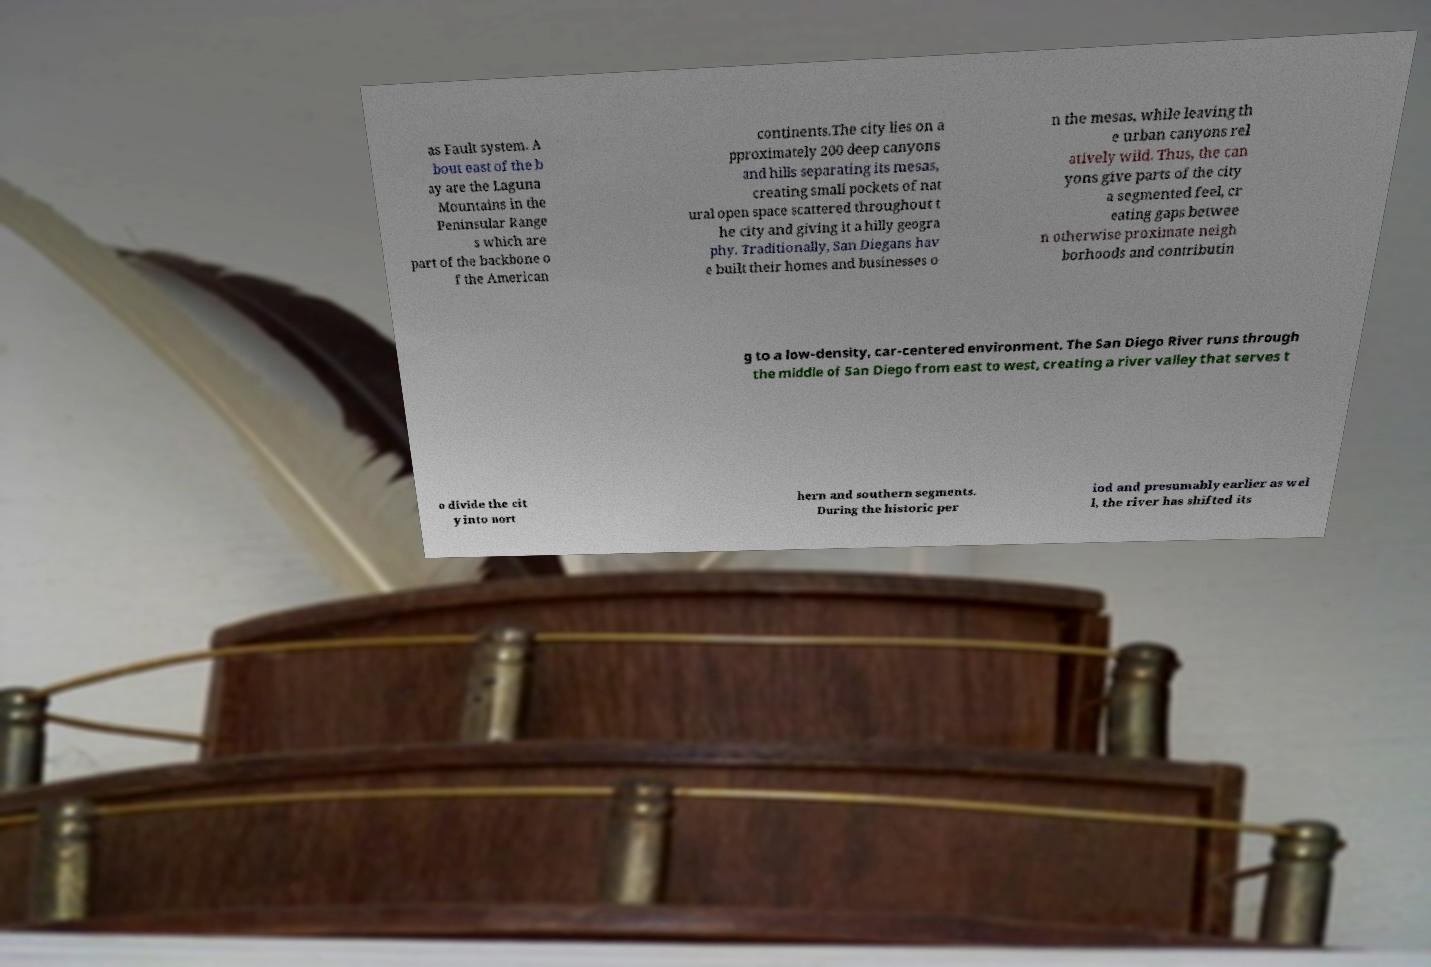Please identify and transcribe the text found in this image. as Fault system. A bout east of the b ay are the Laguna Mountains in the Peninsular Range s which are part of the backbone o f the American continents.The city lies on a pproximately 200 deep canyons and hills separating its mesas, creating small pockets of nat ural open space scattered throughout t he city and giving it a hilly geogra phy. Traditionally, San Diegans hav e built their homes and businesses o n the mesas, while leaving th e urban canyons rel atively wild. Thus, the can yons give parts of the city a segmented feel, cr eating gaps betwee n otherwise proximate neigh borhoods and contributin g to a low-density, car-centered environment. The San Diego River runs through the middle of San Diego from east to west, creating a river valley that serves t o divide the cit y into nort hern and southern segments. During the historic per iod and presumably earlier as wel l, the river has shifted its 